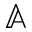<formula> <loc_0><loc_0><loc_500><loc_500>\mathbb { A }</formula> 